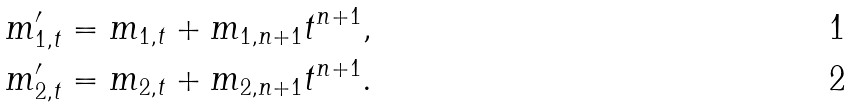<formula> <loc_0><loc_0><loc_500><loc_500>& m ^ { \prime } _ { 1 , t } = m _ { 1 , t } + m _ { 1 , n + 1 } t ^ { n + 1 } , \\ & m ^ { \prime } _ { 2 , t } = m _ { 2 , t } + m _ { 2 , n + 1 } t ^ { n + 1 } .</formula> 